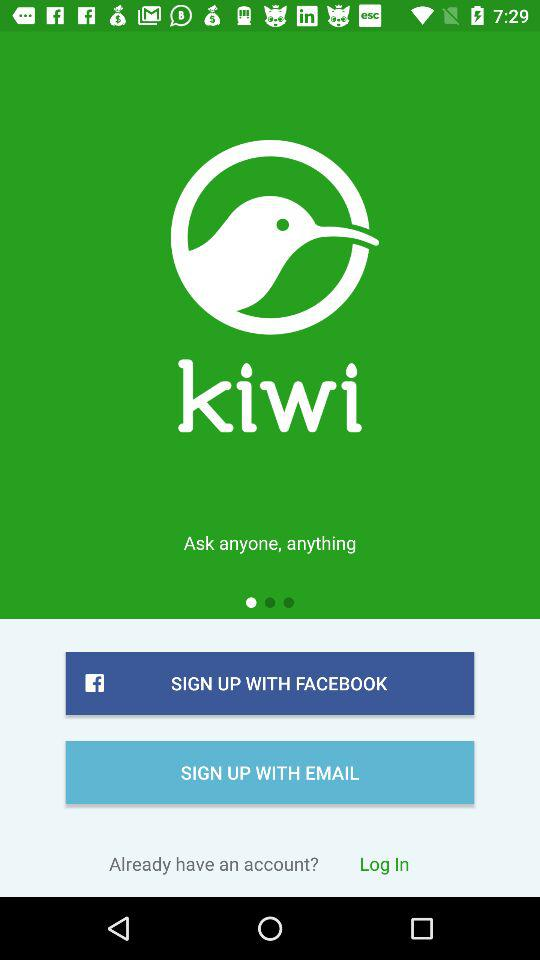How long does it take to sign up with "EMAIL"?
When the provided information is insufficient, respond with <no answer>. <no answer> 